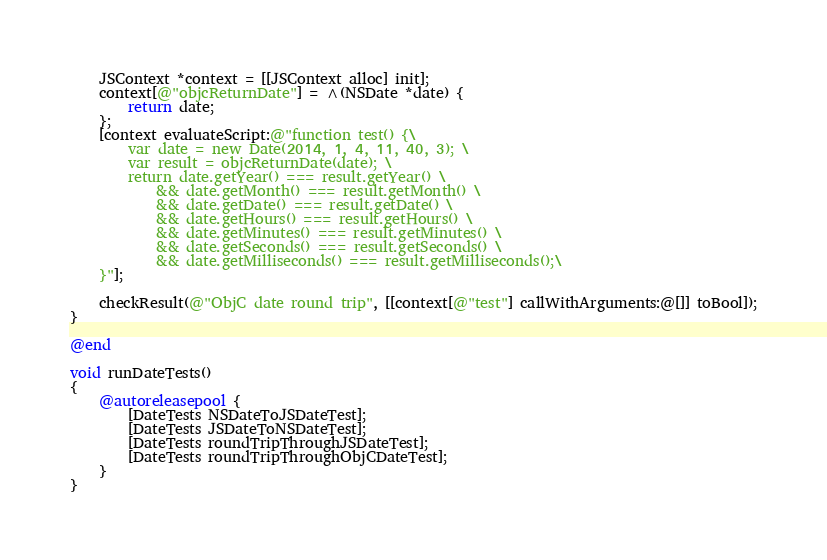<code> <loc_0><loc_0><loc_500><loc_500><_ObjectiveC_>    JSContext *context = [[JSContext alloc] init];
    context[@"objcReturnDate"] = ^(NSDate *date) {
        return date;
    };
    [context evaluateScript:@"function test() {\
        var date = new Date(2014, 1, 4, 11, 40, 3); \
        var result = objcReturnDate(date); \
        return date.getYear() === result.getYear() \
            && date.getMonth() === result.getMonth() \
            && date.getDate() === result.getDate() \
            && date.getHours() === result.getHours() \
            && date.getMinutes() === result.getMinutes() \
            && date.getSeconds() === result.getSeconds() \
            && date.getMilliseconds() === result.getMilliseconds();\
    }"];
    
    checkResult(@"ObjC date round trip", [[context[@"test"] callWithArguments:@[]] toBool]);
}

@end

void runDateTests()
{
    @autoreleasepool {
        [DateTests NSDateToJSDateTest];
        [DateTests JSDateToNSDateTest];
        [DateTests roundTripThroughJSDateTest];
        [DateTests roundTripThroughObjCDateTest];
    }
}
</code> 